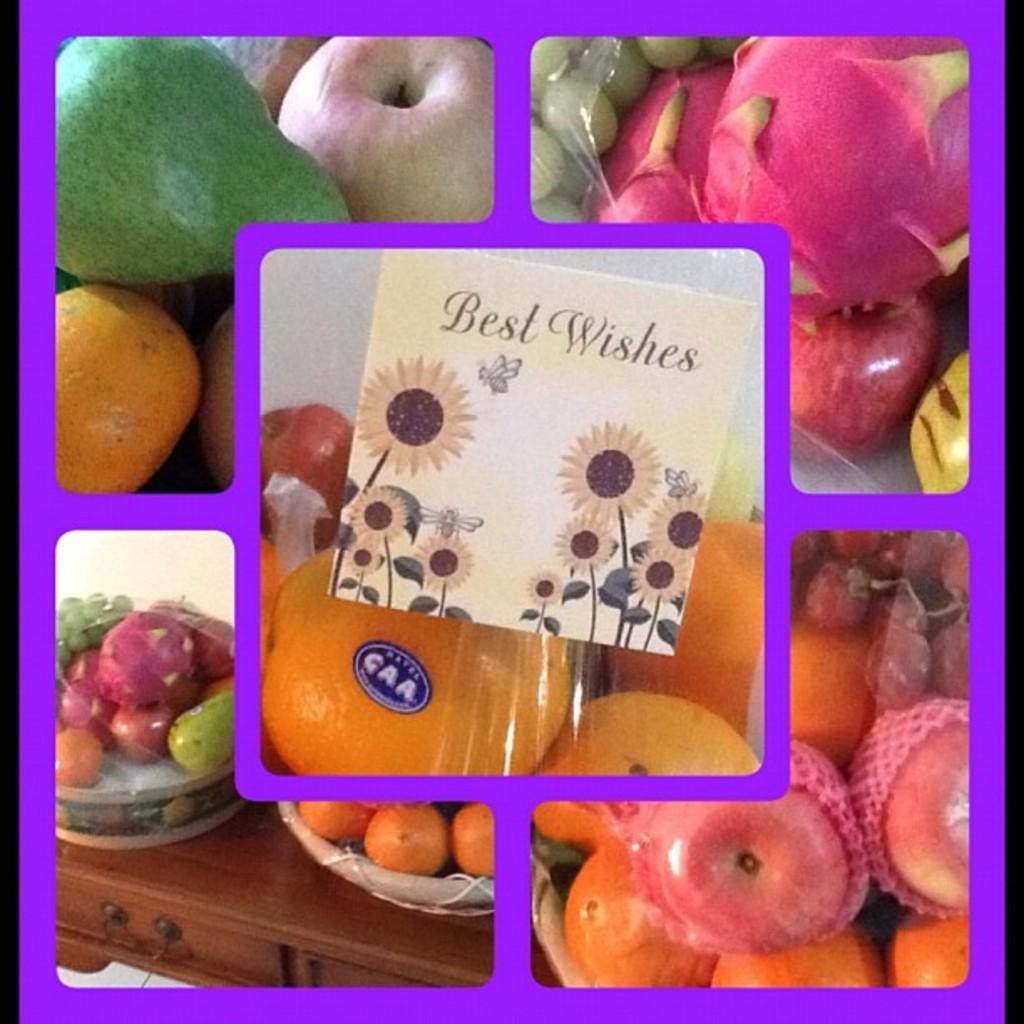Can you describe this image briefly? This is a collage picture, we can see there are different kinds of fruits and in one image there are baskets on a wooden object. 